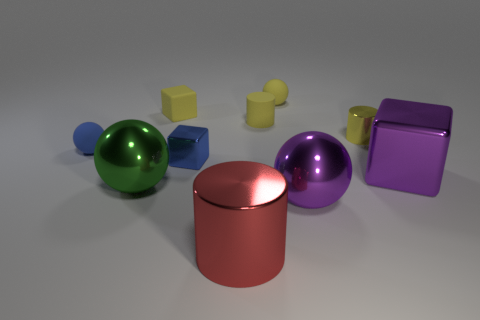Subtract all cubes. How many objects are left? 7 Subtract all tiny cyan rubber cylinders. Subtract all large metallic blocks. How many objects are left? 9 Add 6 large red metallic cylinders. How many large red metallic cylinders are left? 7 Add 6 tiny shiny cylinders. How many tiny shiny cylinders exist? 7 Subtract 1 red cylinders. How many objects are left? 9 